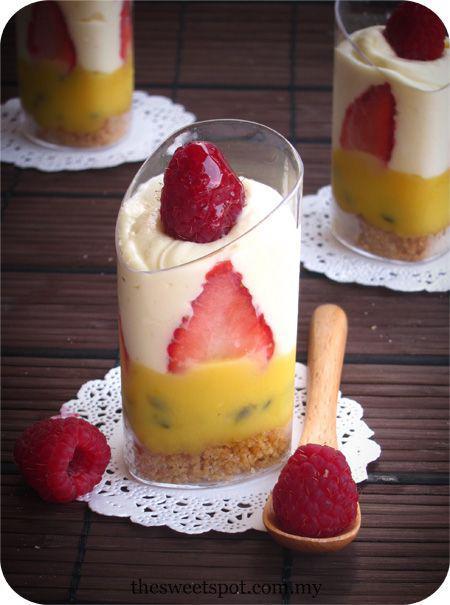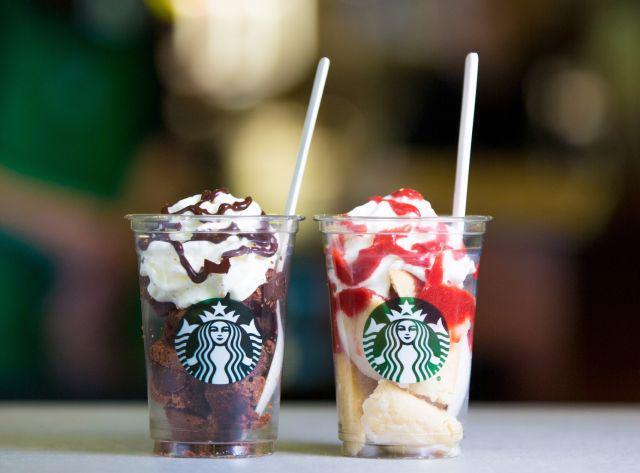The first image is the image on the left, the second image is the image on the right. Analyze the images presented: Is the assertion "An image shows at least two layered desserts served in clear non-footed glasses and each garnished with a single red berry." valid? Answer yes or no. Yes. The first image is the image on the left, the second image is the image on the right. Evaluate the accuracy of this statement regarding the images: "The dessert in the image on the left is served in a single sized serving.". Is it true? Answer yes or no. Yes. 